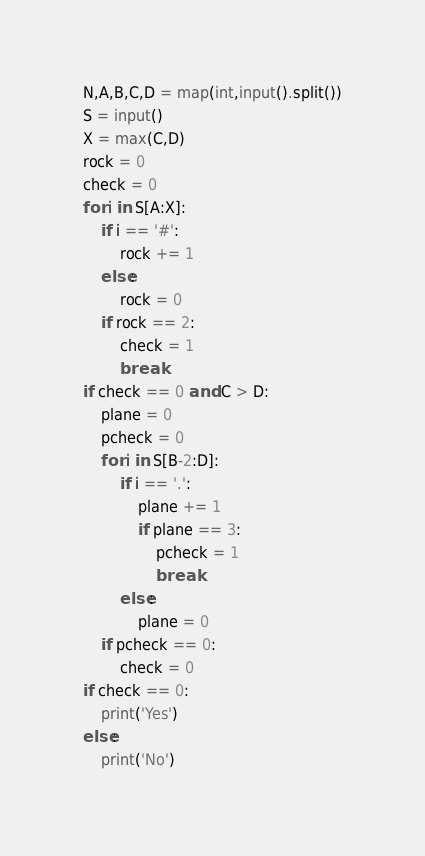Convert code to text. <code><loc_0><loc_0><loc_500><loc_500><_Python_>N,A,B,C,D = map(int,input().split())
S = input()
X = max(C,D)
rock = 0
check = 0
for i in S[A:X]:
    if i == '#':
        rock += 1
    else:
        rock = 0
    if rock == 2:
        check = 1
        break
if check == 0 and C > D:
    plane = 0
    pcheck = 0
    for i in S[B-2:D]:
        if i == '.':
            plane += 1
            if plane == 3:
                pcheck = 1
                break
        else:
            plane = 0
    if pcheck == 0:
        check = 0
if check == 0:
    print('Yes')
else:
    print('No')</code> 